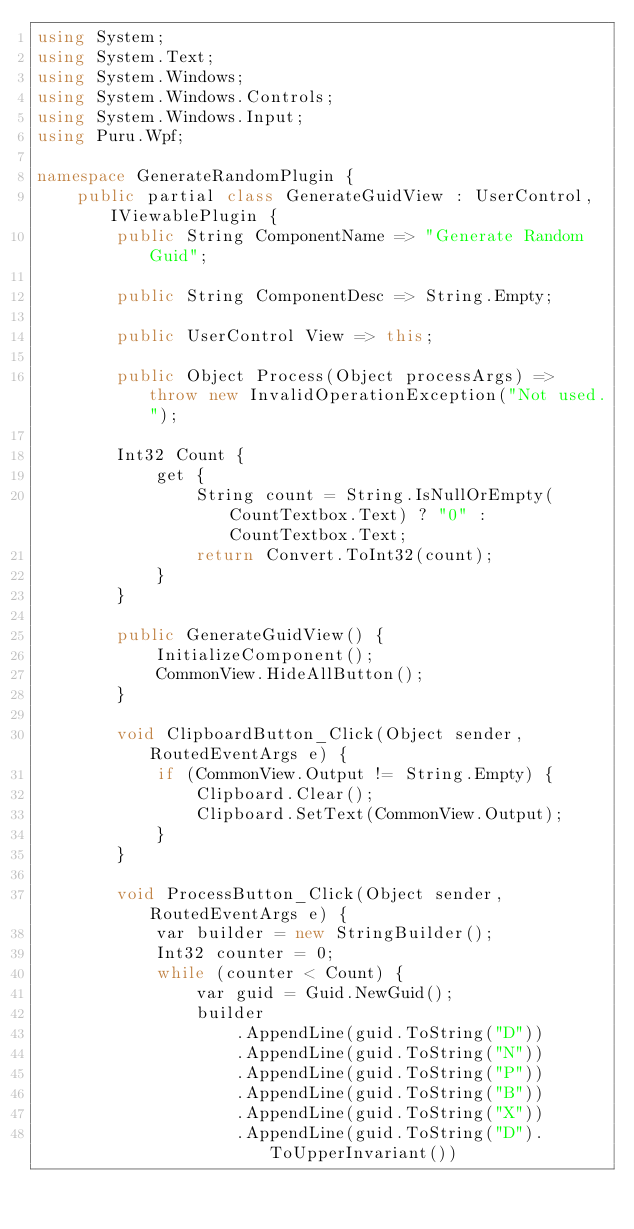Convert code to text. <code><loc_0><loc_0><loc_500><loc_500><_C#_>using System;
using System.Text;
using System.Windows;
using System.Windows.Controls;
using System.Windows.Input;
using Puru.Wpf;

namespace GenerateRandomPlugin {
    public partial class GenerateGuidView : UserControl, IViewablePlugin {
        public String ComponentName => "Generate Random Guid";

        public String ComponentDesc => String.Empty;

        public UserControl View => this;

        public Object Process(Object processArgs) => throw new InvalidOperationException("Not used.");

        Int32 Count {
            get {
                String count = String.IsNullOrEmpty(CountTextbox.Text) ? "0" : CountTextbox.Text;
                return Convert.ToInt32(count);
            }
        }

        public GenerateGuidView() {
            InitializeComponent();
            CommonView.HideAllButton();
        }

        void ClipboardButton_Click(Object sender, RoutedEventArgs e) {
            if (CommonView.Output != String.Empty) {
                Clipboard.Clear();
                Clipboard.SetText(CommonView.Output);
            }
        }

        void ProcessButton_Click(Object sender, RoutedEventArgs e) {
            var builder = new StringBuilder();
            Int32 counter = 0;
            while (counter < Count) {
                var guid = Guid.NewGuid();
                builder
                    .AppendLine(guid.ToString("D"))
                    .AppendLine(guid.ToString("N"))
                    .AppendLine(guid.ToString("P"))
                    .AppendLine(guid.ToString("B"))
                    .AppendLine(guid.ToString("X"))
                    .AppendLine(guid.ToString("D").ToUpperInvariant())</code> 